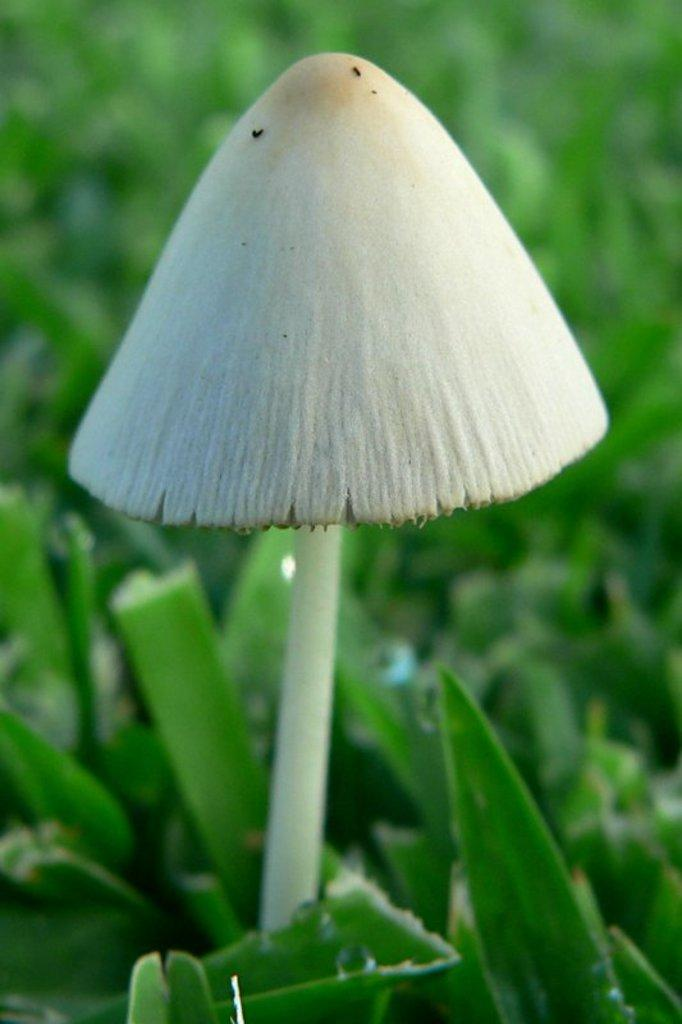What is the main subject of the image? There is a mushroom in the image. What other natural elements can be seen in the image? There are leaves in the image. How would you describe the background of the image? The background of the image is green and blurry. What type of plastic material can be seen in the image? There is no plastic material present in the image. What kind of beast is interacting with the mushroom in the image? There is no beast present in the image; it only features a mushroom and leaves. 